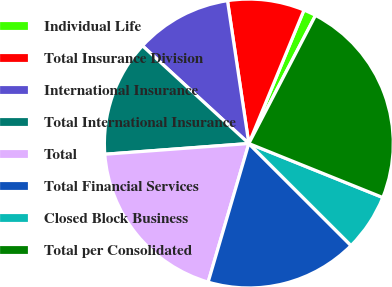<chart> <loc_0><loc_0><loc_500><loc_500><pie_chart><fcel>Individual Life<fcel>Total Insurance Division<fcel>International Insurance<fcel>Total International Insurance<fcel>Total<fcel>Total Financial Services<fcel>Closed Block Business<fcel>Total per Consolidated<nl><fcel>1.4%<fcel>8.6%<fcel>10.81%<fcel>13.01%<fcel>19.27%<fcel>17.06%<fcel>6.39%<fcel>23.46%<nl></chart> 